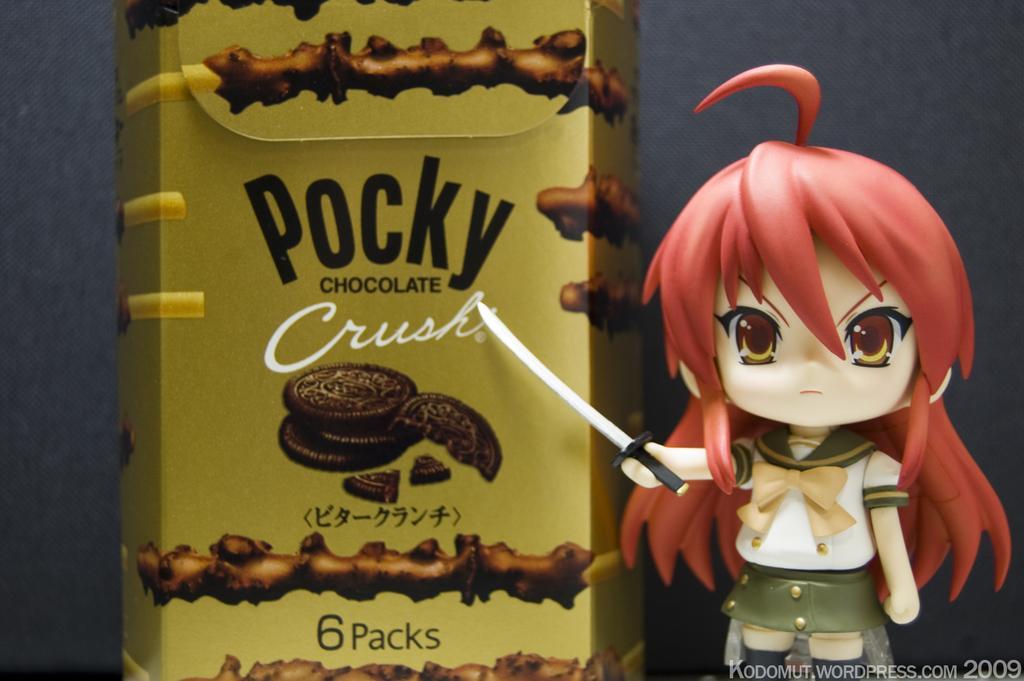Can you describe this image briefly? This is an animated image, in this image there is a cartoon beside a chocolate can. 